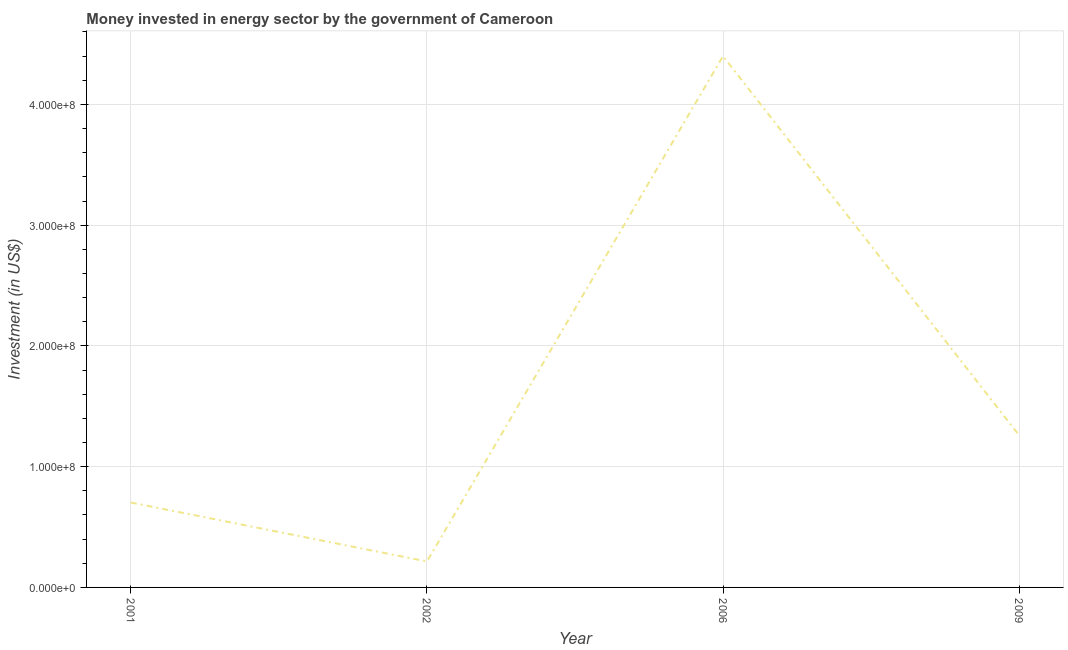What is the investment in energy in 2002?
Provide a succinct answer. 2.15e+07. Across all years, what is the maximum investment in energy?
Your response must be concise. 4.40e+08. Across all years, what is the minimum investment in energy?
Your answer should be compact. 2.15e+07. In which year was the investment in energy minimum?
Make the answer very short. 2002. What is the sum of the investment in energy?
Your answer should be compact. 6.58e+08. What is the difference between the investment in energy in 2001 and 2009?
Make the answer very short. -5.57e+07. What is the average investment in energy per year?
Your response must be concise. 1.64e+08. What is the median investment in energy?
Keep it short and to the point. 9.82e+07. Do a majority of the years between 2001 and 2006 (inclusive) have investment in energy greater than 200000000 US$?
Your response must be concise. No. What is the ratio of the investment in energy in 2001 to that in 2009?
Your response must be concise. 0.56. Is the difference between the investment in energy in 2002 and 2006 greater than the difference between any two years?
Make the answer very short. Yes. What is the difference between the highest and the second highest investment in energy?
Offer a very short reply. 3.14e+08. What is the difference between the highest and the lowest investment in energy?
Your response must be concise. 4.18e+08. In how many years, is the investment in energy greater than the average investment in energy taken over all years?
Give a very brief answer. 1. Does the investment in energy monotonically increase over the years?
Your answer should be very brief. No. How many lines are there?
Your response must be concise. 1. Does the graph contain grids?
Make the answer very short. Yes. What is the title of the graph?
Offer a terse response. Money invested in energy sector by the government of Cameroon. What is the label or title of the Y-axis?
Provide a short and direct response. Investment (in US$). What is the Investment (in US$) of 2001?
Your response must be concise. 7.03e+07. What is the Investment (in US$) in 2002?
Your answer should be very brief. 2.15e+07. What is the Investment (in US$) of 2006?
Keep it short and to the point. 4.40e+08. What is the Investment (in US$) in 2009?
Your answer should be very brief. 1.26e+08. What is the difference between the Investment (in US$) in 2001 and 2002?
Ensure brevity in your answer.  4.88e+07. What is the difference between the Investment (in US$) in 2001 and 2006?
Provide a succinct answer. -3.70e+08. What is the difference between the Investment (in US$) in 2001 and 2009?
Your response must be concise. -5.57e+07. What is the difference between the Investment (in US$) in 2002 and 2006?
Offer a terse response. -4.18e+08. What is the difference between the Investment (in US$) in 2002 and 2009?
Make the answer very short. -1.04e+08. What is the difference between the Investment (in US$) in 2006 and 2009?
Provide a short and direct response. 3.14e+08. What is the ratio of the Investment (in US$) in 2001 to that in 2002?
Your answer should be compact. 3.27. What is the ratio of the Investment (in US$) in 2001 to that in 2006?
Keep it short and to the point. 0.16. What is the ratio of the Investment (in US$) in 2001 to that in 2009?
Offer a terse response. 0.56. What is the ratio of the Investment (in US$) in 2002 to that in 2006?
Ensure brevity in your answer.  0.05. What is the ratio of the Investment (in US$) in 2002 to that in 2009?
Your answer should be compact. 0.17. What is the ratio of the Investment (in US$) in 2006 to that in 2009?
Your answer should be compact. 3.49. 